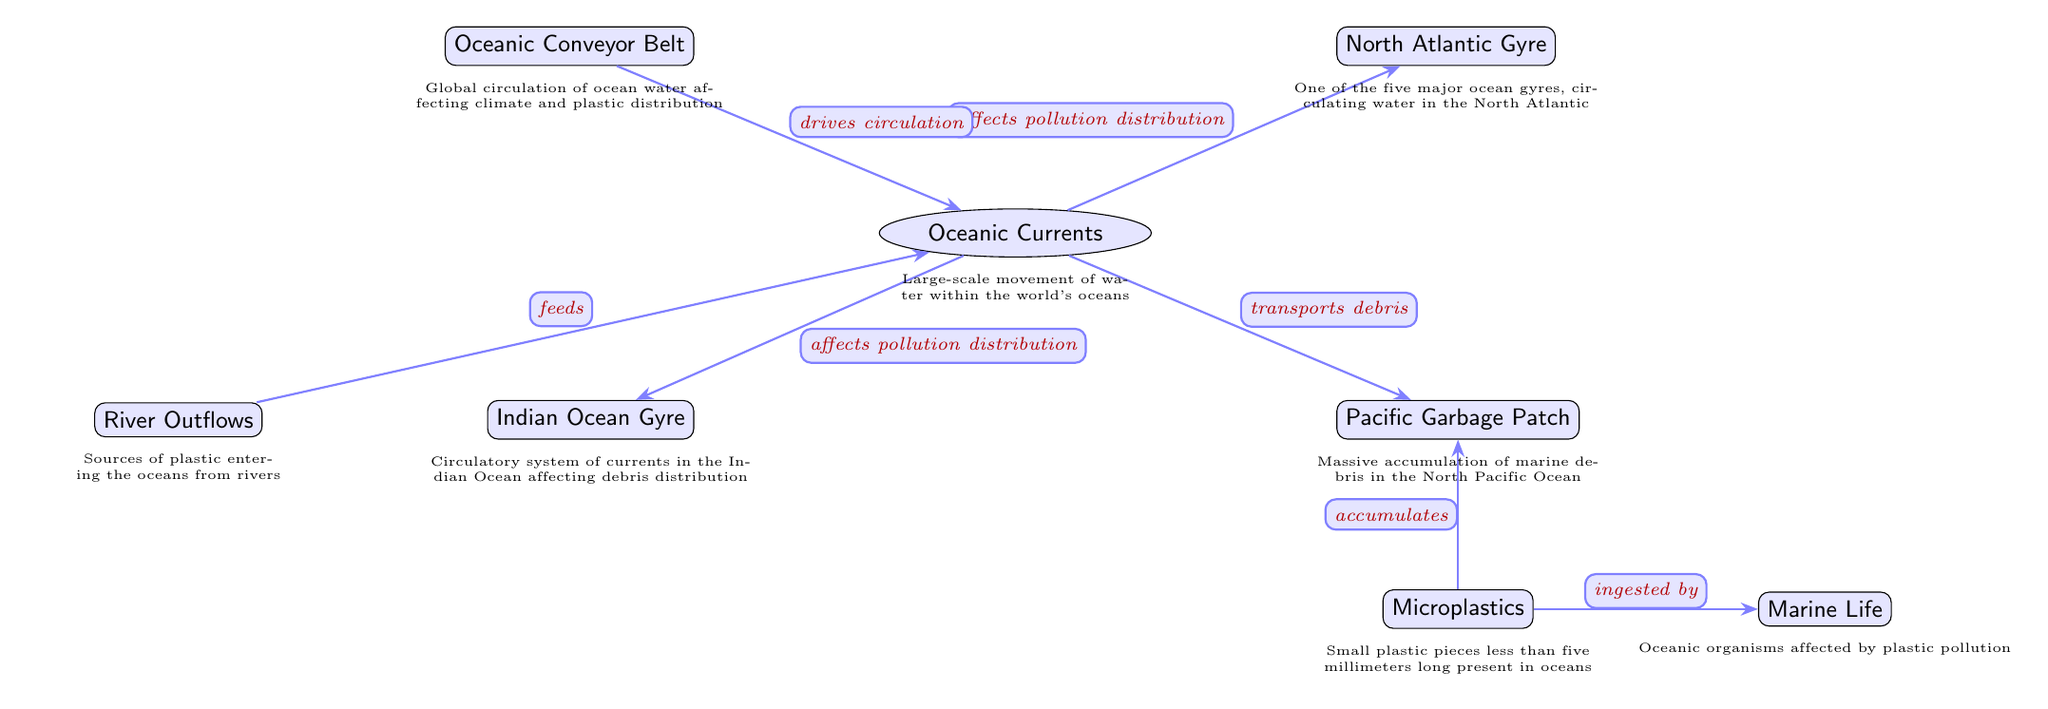What is the main topic covered in the diagram? The diagram illustrates 'Oceanic Currents and Their Role in Plastic Pollution Distribution', which indicates its focus on the interaction between ocean currents and plastic waste in the marine environment.
Answer: Oceanic Currents and Their Role in Plastic Pollution Distribution How many nodes are present in the diagram? By counting each labeled bubble or node in the diagram, we find that there are a total of eight nodes.
Answer: eight What type of pollution does the 'Pacific Garbage Patch' mainly accumulate? The 'Pacific Garbage Patch' specifically consists of marine debris, as indicated by the label directly connected to it in the diagram.
Answer: marine debris Which ocean current drives the circulation depicted in the diagram? The connection indicates that the 'Oceanic Conveyor Belt' drives the circulation of water within 'Oceanic Currents', as shown by the edge labeled "drives circulation."
Answer: Oceanic Conveyor Belt What does the arrow from 'River Outflows' indicate? The arrow labeled "feeds" from 'River Outflows' to 'Oceanic Currents' indicates that river outflows are sources of plastic, contributing to pollution in ocean currents.
Answer: feeds What impact do oceanic currents have on plastic pollution distribution? The diagram shows that oceanic currents "affect pollution distribution" in both the 'North Atlantic Gyre' and the 'Indian Ocean Gyre', implying a significant impact.
Answer: affect pollution distribution How do microplastics relate to marine life in the diagram? The label on the edge shows that microplastics "are ingested by" marine life, illustrating a direct interaction and impact of microplastic pollution on marine organisms.
Answer: ingested by Which component is identified as a source of plastic entering the oceans? The 'River Outflows' node is specifically identified as a source contributing plastic into the oceans as indicated by its labeled arrow towards 'Oceanic Currents'.
Answer: River Outflows 